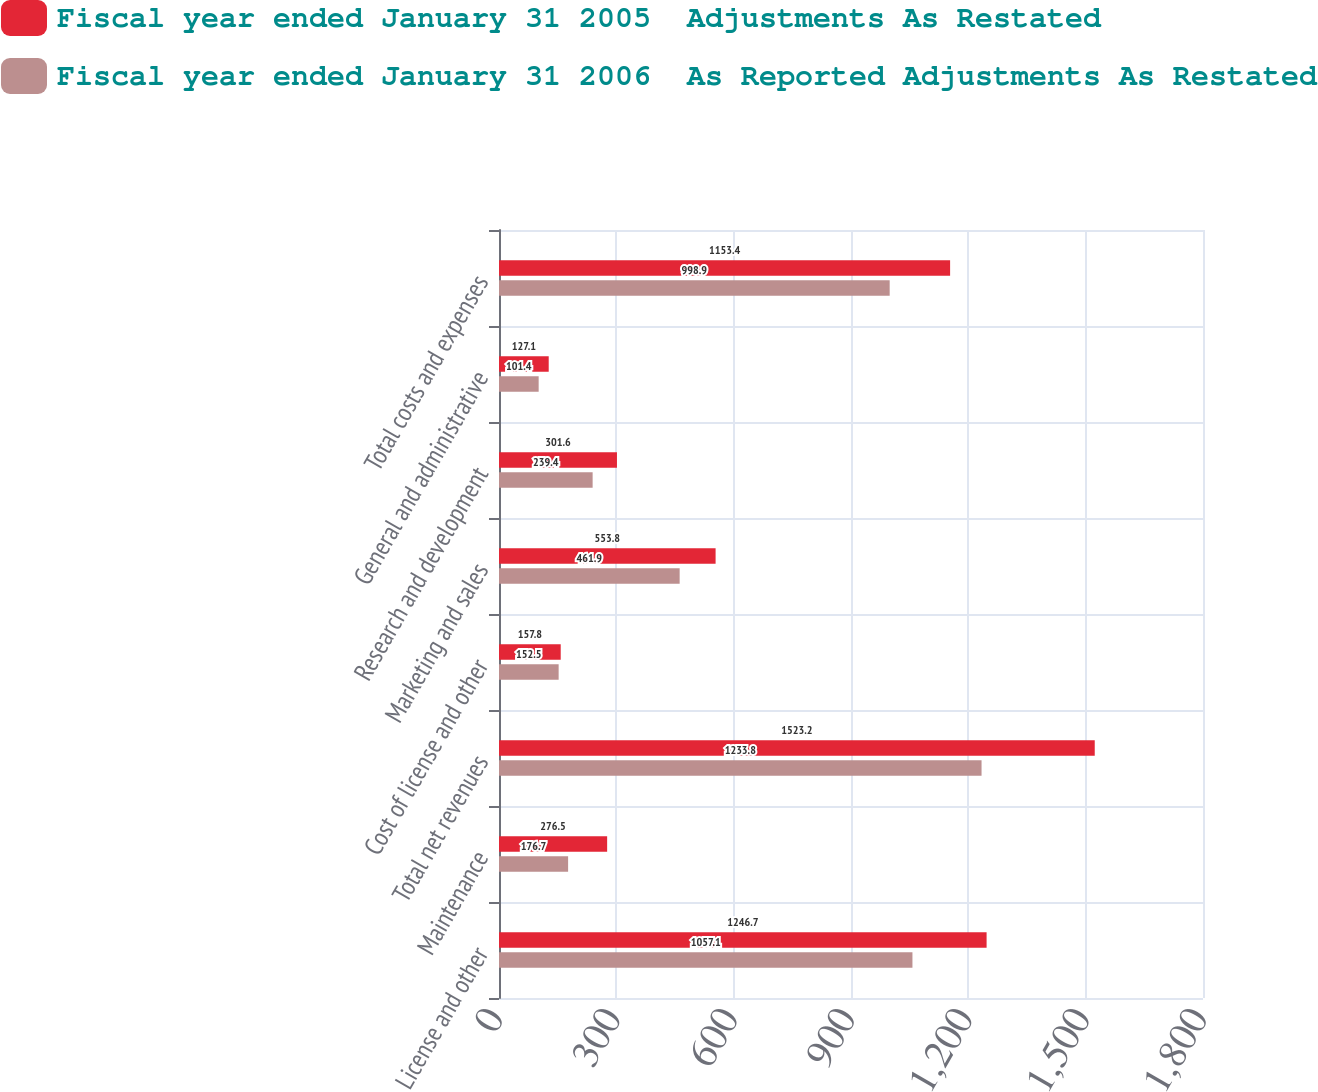<chart> <loc_0><loc_0><loc_500><loc_500><stacked_bar_chart><ecel><fcel>License and other<fcel>Maintenance<fcel>Total net revenues<fcel>Cost of license and other<fcel>Marketing and sales<fcel>Research and development<fcel>General and administrative<fcel>Total costs and expenses<nl><fcel>Fiscal year ended January 31 2005  Adjustments As Restated<fcel>1246.7<fcel>276.5<fcel>1523.2<fcel>157.8<fcel>553.8<fcel>301.6<fcel>127.1<fcel>1153.4<nl><fcel>Fiscal year ended January 31 2006  As Reported Adjustments As Restated<fcel>1057.1<fcel>176.7<fcel>1233.8<fcel>152.5<fcel>461.9<fcel>239.4<fcel>101.4<fcel>998.9<nl></chart> 